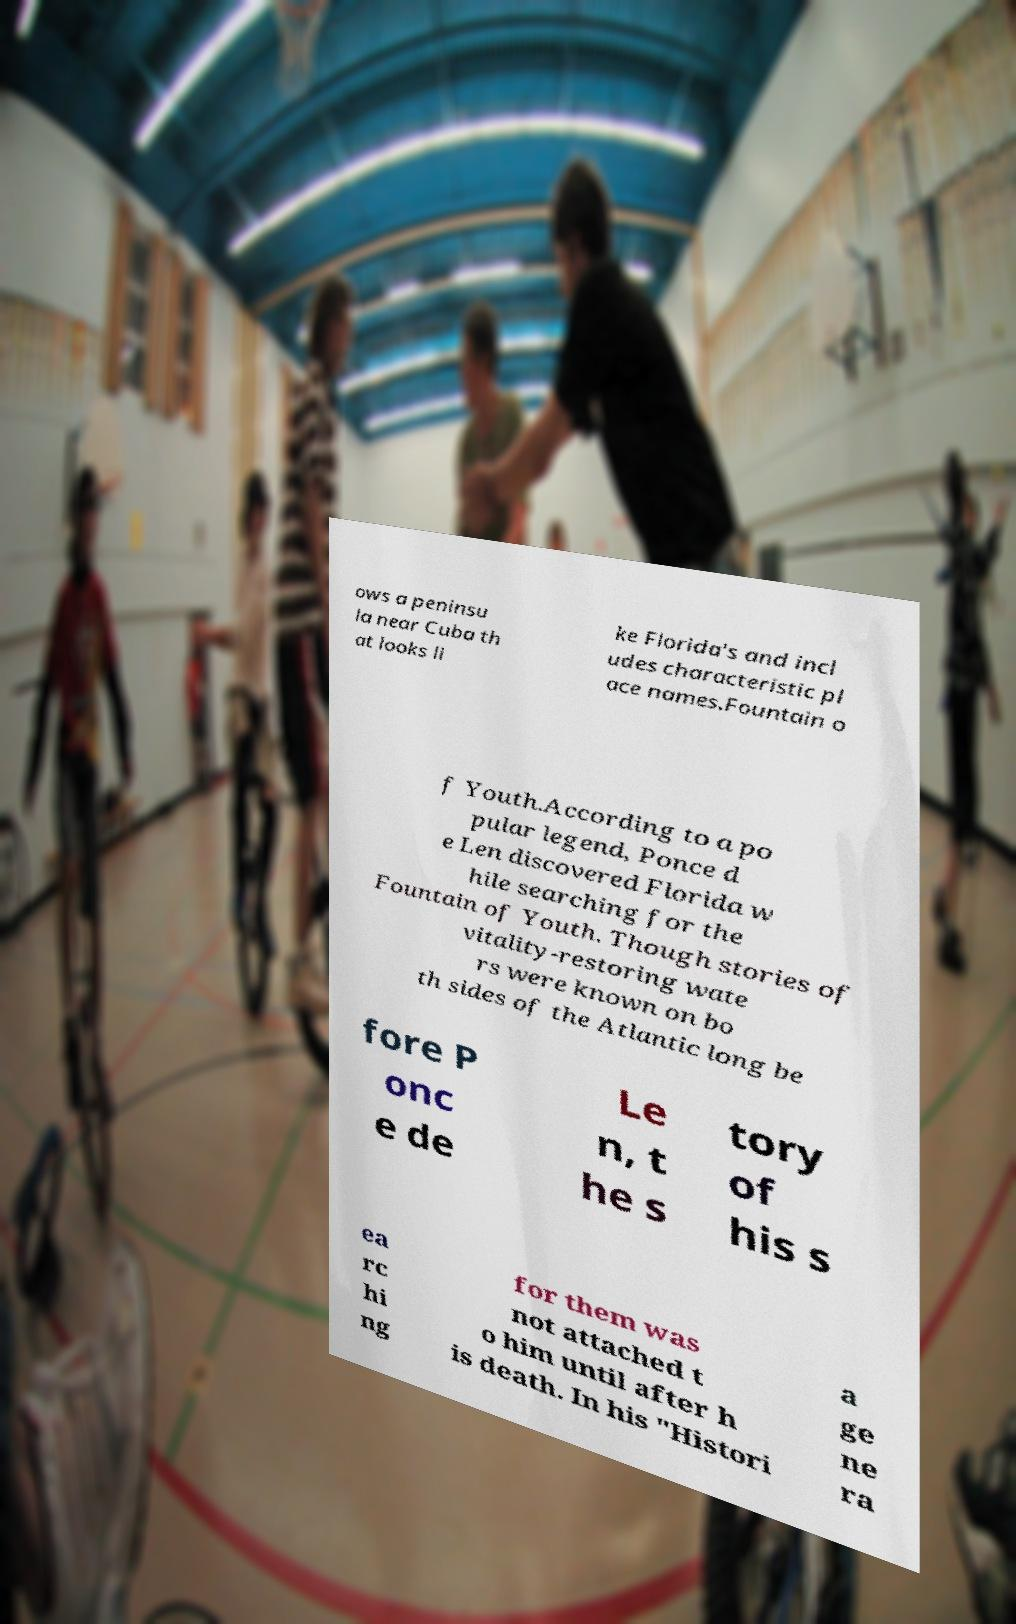Could you assist in decoding the text presented in this image and type it out clearly? ows a peninsu la near Cuba th at looks li ke Florida's and incl udes characteristic pl ace names.Fountain o f Youth.According to a po pular legend, Ponce d e Len discovered Florida w hile searching for the Fountain of Youth. Though stories of vitality-restoring wate rs were known on bo th sides of the Atlantic long be fore P onc e de Le n, t he s tory of his s ea rc hi ng for them was not attached t o him until after h is death. In his "Histori a ge ne ra 